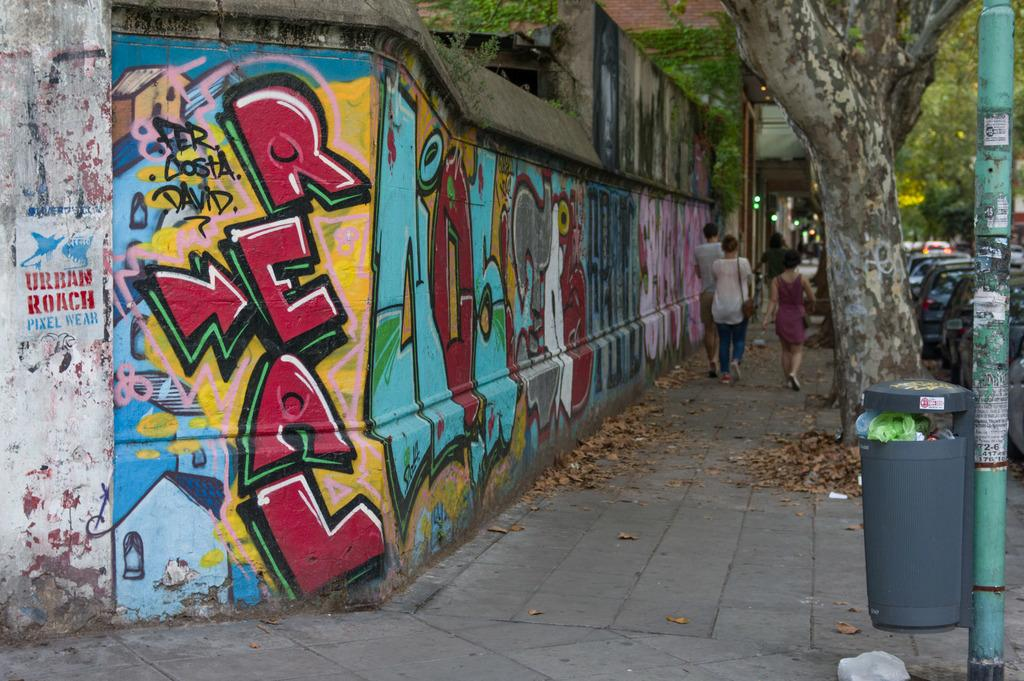What can be seen on the right side of the image? There are persons, vehicles, a tree, a dustbin, and a pole on the right side of the image. Can you describe the persons in the image? The persons in the image are on the right side, but their specific characteristics are not mentioned in the facts. What type of vehicles are present in the image? The facts do not specify the type of vehicles in the image. What is the purpose of the dustbin in the image? The purpose of the dustbin in the image is not mentioned in the facts. What type of tent can be seen in the image? There is no tent present in the image. What color is the coat worn by the person in the image? There is no person wearing a coat in the image. How many pancakes are stacked on the pole in the image? There is no pole with pancakes in the image. 